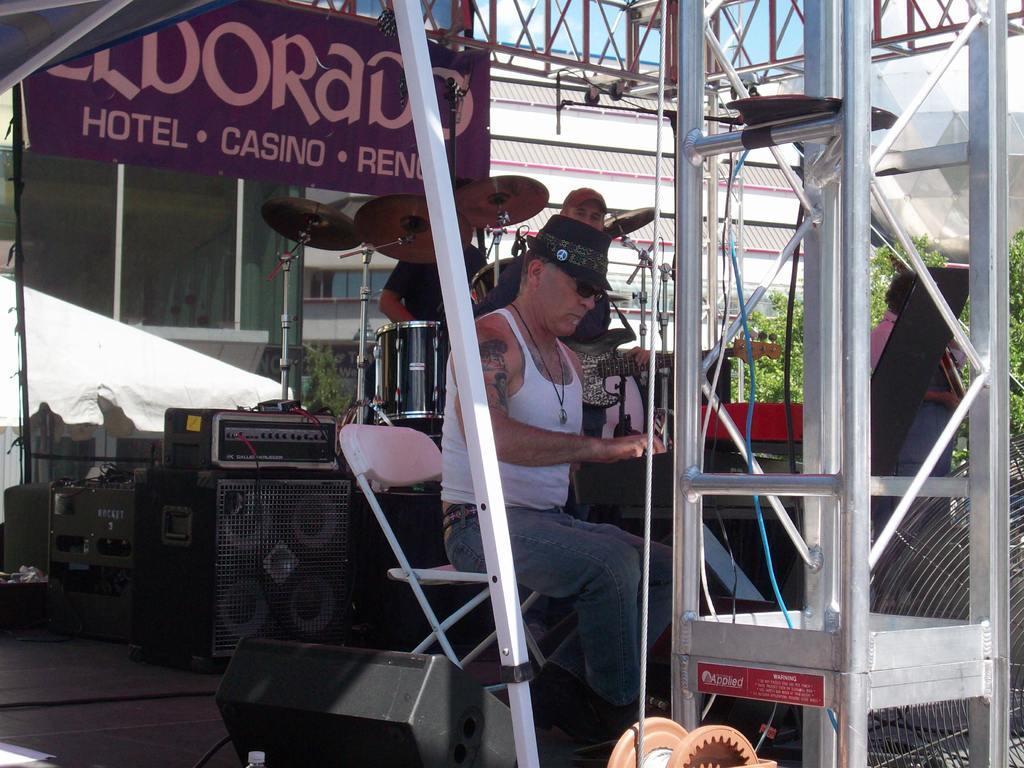In one or two sentences, can you explain what this image depicts? There is man who is sitting on a steel chair and playing a piano. On his back side we can see two peoples are standing near to the table. On the table there is a drum and some musical instruments. On the top left we can see banner and that written a hotel casino. On the right we can see a plant. On the top of the image we can see a sky and some clouds. 